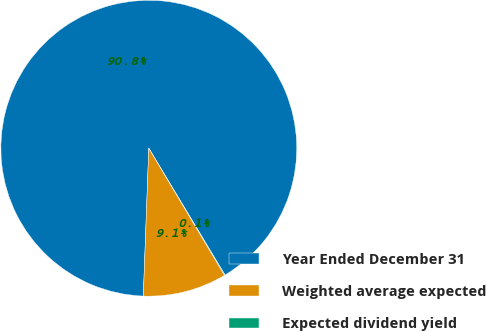Convert chart to OTSL. <chart><loc_0><loc_0><loc_500><loc_500><pie_chart><fcel>Year Ended December 31<fcel>Weighted average expected<fcel>Expected dividend yield<nl><fcel>90.79%<fcel>9.14%<fcel>0.07%<nl></chart> 